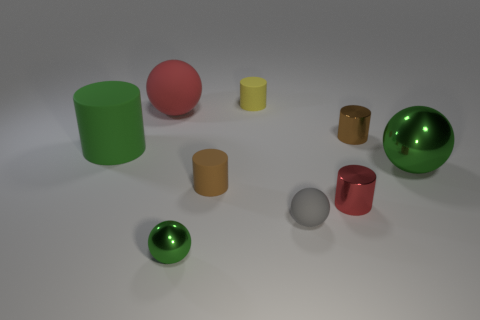Subtract 1 cylinders. How many cylinders are left? 4 Subtract all red cylinders. How many cylinders are left? 4 Subtract all cyan cylinders. Subtract all brown spheres. How many cylinders are left? 5 Add 1 red matte objects. How many objects exist? 10 Subtract all cylinders. How many objects are left? 4 Add 4 small brown metal cylinders. How many small brown metal cylinders exist? 5 Subtract 0 cyan blocks. How many objects are left? 9 Subtract all big red rubber things. Subtract all green metal objects. How many objects are left? 6 Add 9 big matte balls. How many big matte balls are left? 10 